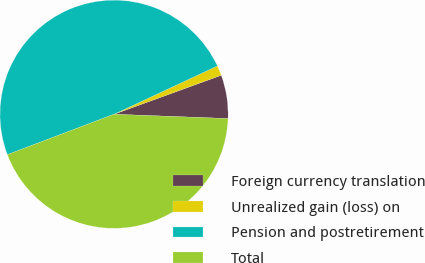Convert chart. <chart><loc_0><loc_0><loc_500><loc_500><pie_chart><fcel>Foreign currency translation<fcel>Unrealized gain (loss) on<fcel>Pension and postretirement<fcel>Total<nl><fcel>6.15%<fcel>1.41%<fcel>48.8%<fcel>43.64%<nl></chart> 